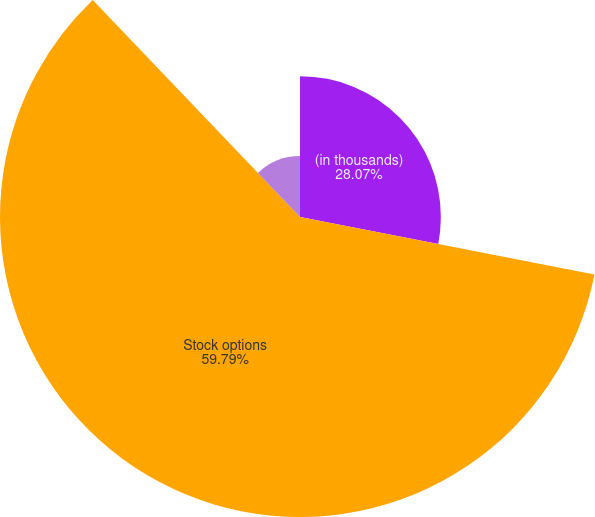Convert chart to OTSL. <chart><loc_0><loc_0><loc_500><loc_500><pie_chart><fcel>(in thousands)<fcel>Stock options<fcel>Restricted shares<nl><fcel>28.07%<fcel>59.79%<fcel>12.14%<nl></chart> 